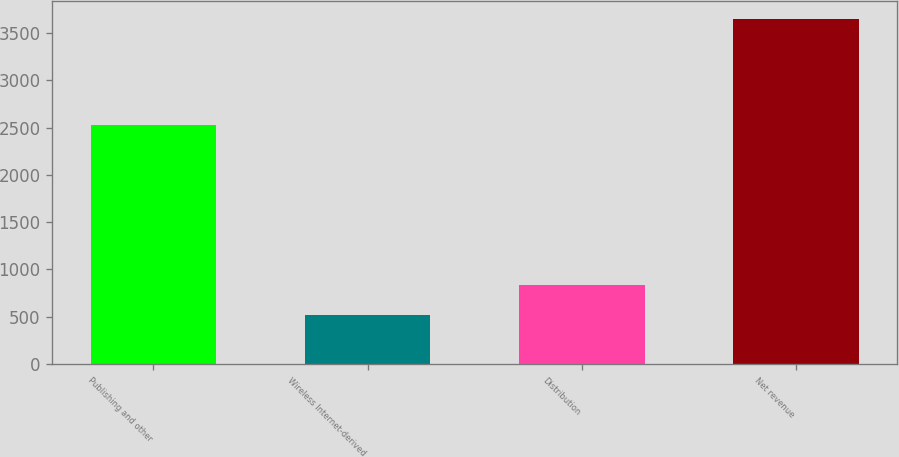<chart> <loc_0><loc_0><loc_500><loc_500><bar_chart><fcel>Publishing and other<fcel>Wireless Internet-derived<fcel>Distribution<fcel>Net revenue<nl><fcel>2526<fcel>522<fcel>835.2<fcel>3654<nl></chart> 